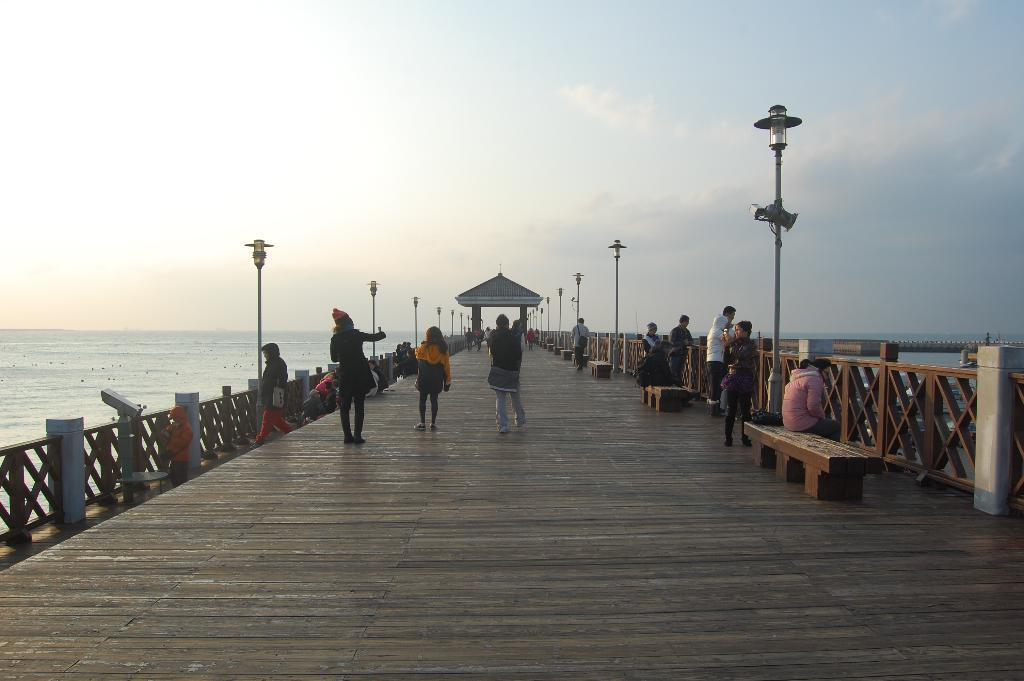What is the setting of the image? The group of men and women is standing on a wooden bridge. What can be seen on both sides of the bridge? There is a river on both sides of the bridge. What architectural features are visible in the background of the image? There is an arch and a dome lamp post in the background of the image. What type of pollution can be seen in the image? There is no pollution visible in the image. What color is the ink used to write on the wooden bridge? There is no writing or ink present on the wooden bridge in the image. 